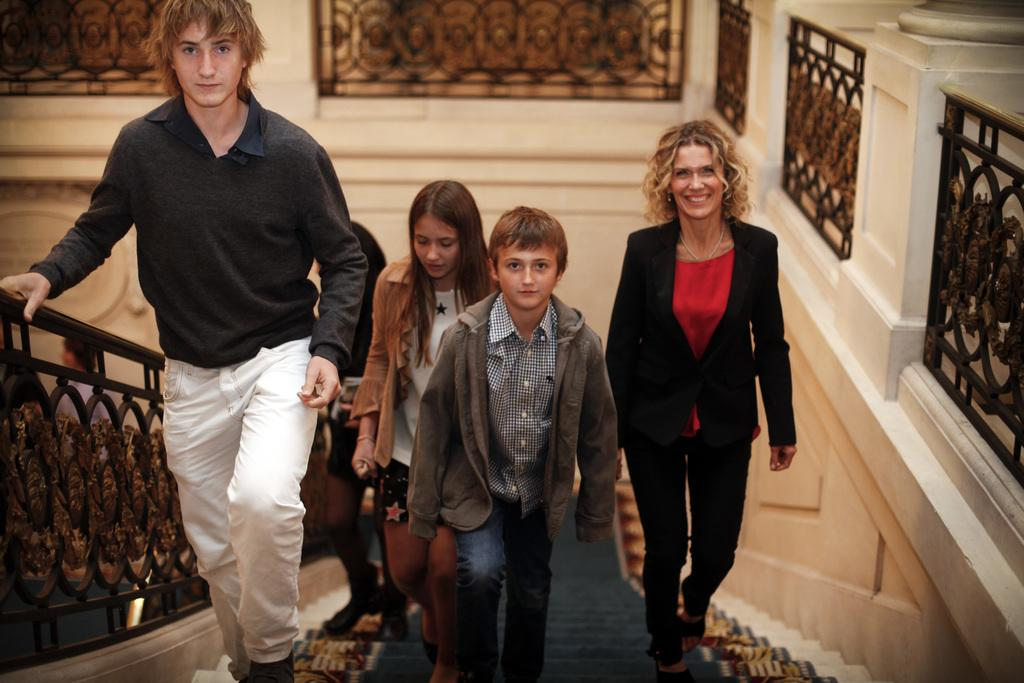How many individuals are present in the image? There are many people in the image. What are the people doing in the image? The people are climbing up from the stairs. What is located beside the people in the image? There is a fence beside the people. How many trees can be seen in the image? There are no trees visible in the image; it primarily features people climbing up from the stairs and a fence beside them. 